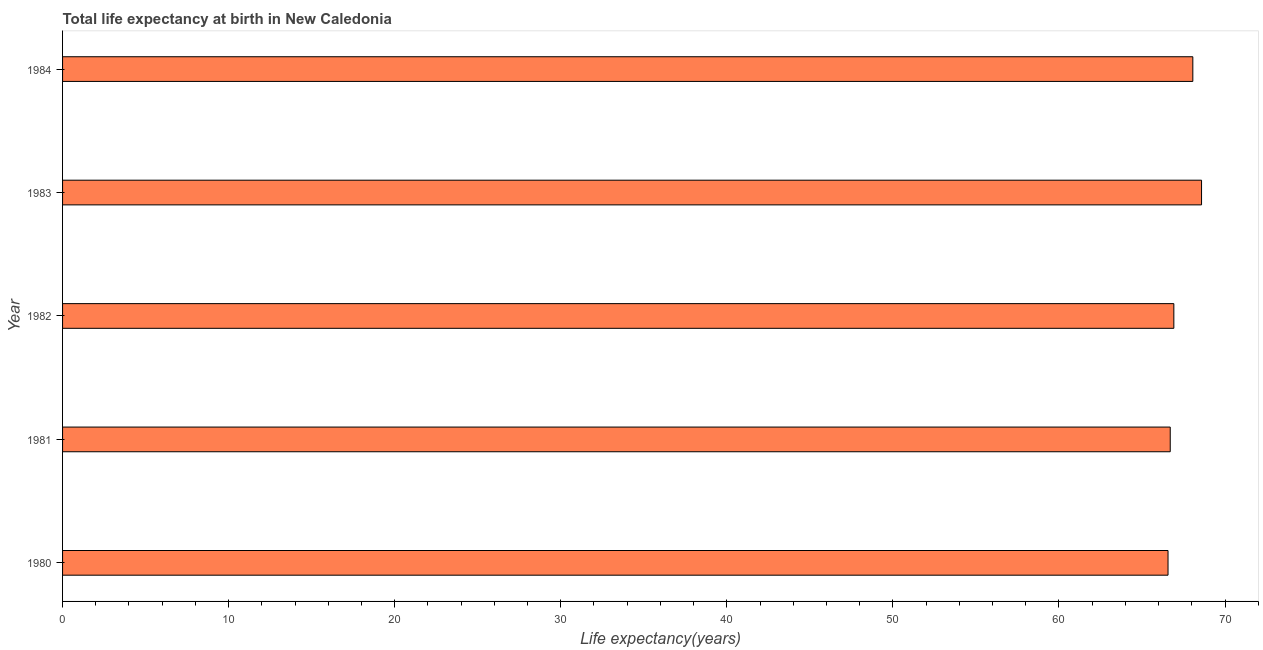Does the graph contain any zero values?
Provide a succinct answer. No. Does the graph contain grids?
Provide a succinct answer. No. What is the title of the graph?
Ensure brevity in your answer.  Total life expectancy at birth in New Caledonia. What is the label or title of the X-axis?
Offer a very short reply. Life expectancy(years). What is the life expectancy at birth in 1981?
Your answer should be compact. 66.7. Across all years, what is the maximum life expectancy at birth?
Your answer should be compact. 68.59. Across all years, what is the minimum life expectancy at birth?
Provide a short and direct response. 66.57. In which year was the life expectancy at birth maximum?
Provide a succinct answer. 1983. In which year was the life expectancy at birth minimum?
Provide a short and direct response. 1980. What is the sum of the life expectancy at birth?
Ensure brevity in your answer.  336.84. What is the difference between the life expectancy at birth in 1980 and 1983?
Make the answer very short. -2.02. What is the average life expectancy at birth per year?
Ensure brevity in your answer.  67.37. What is the median life expectancy at birth?
Your answer should be very brief. 66.92. In how many years, is the life expectancy at birth greater than 30 years?
Offer a very short reply. 5. Do a majority of the years between 1984 and 1980 (inclusive) have life expectancy at birth greater than 16 years?
Keep it short and to the point. Yes. What is the ratio of the life expectancy at birth in 1980 to that in 1981?
Offer a very short reply. 1. Is the difference between the life expectancy at birth in 1981 and 1984 greater than the difference between any two years?
Your answer should be very brief. No. What is the difference between the highest and the second highest life expectancy at birth?
Make the answer very short. 0.52. What is the difference between the highest and the lowest life expectancy at birth?
Provide a succinct answer. 2.02. In how many years, is the life expectancy at birth greater than the average life expectancy at birth taken over all years?
Provide a succinct answer. 2. What is the difference between two consecutive major ticks on the X-axis?
Your answer should be very brief. 10. Are the values on the major ticks of X-axis written in scientific E-notation?
Ensure brevity in your answer.  No. What is the Life expectancy(years) of 1980?
Your answer should be compact. 66.57. What is the Life expectancy(years) in 1981?
Give a very brief answer. 66.7. What is the Life expectancy(years) of 1982?
Make the answer very short. 66.92. What is the Life expectancy(years) of 1983?
Your response must be concise. 68.59. What is the Life expectancy(years) of 1984?
Provide a succinct answer. 68.06. What is the difference between the Life expectancy(years) in 1980 and 1981?
Offer a very short reply. -0.13. What is the difference between the Life expectancy(years) in 1980 and 1982?
Keep it short and to the point. -0.35. What is the difference between the Life expectancy(years) in 1980 and 1983?
Your response must be concise. -2.02. What is the difference between the Life expectancy(years) in 1980 and 1984?
Your response must be concise. -1.49. What is the difference between the Life expectancy(years) in 1981 and 1982?
Keep it short and to the point. -0.22. What is the difference between the Life expectancy(years) in 1981 and 1983?
Ensure brevity in your answer.  -1.89. What is the difference between the Life expectancy(years) in 1981 and 1984?
Your answer should be compact. -1.36. What is the difference between the Life expectancy(years) in 1982 and 1983?
Offer a terse response. -1.67. What is the difference between the Life expectancy(years) in 1982 and 1984?
Give a very brief answer. -1.14. What is the difference between the Life expectancy(years) in 1983 and 1984?
Make the answer very short. 0.52. What is the ratio of the Life expectancy(years) in 1980 to that in 1983?
Your answer should be compact. 0.97. What is the ratio of the Life expectancy(years) in 1982 to that in 1984?
Offer a very short reply. 0.98. 